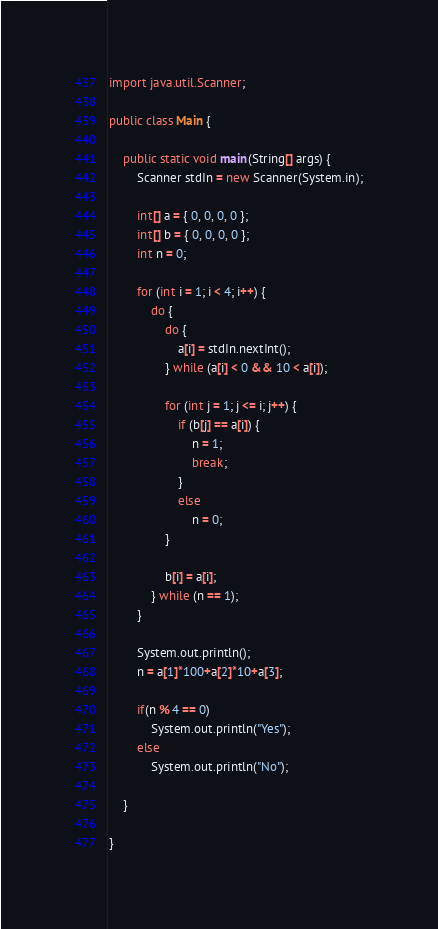Convert code to text. <code><loc_0><loc_0><loc_500><loc_500><_Java_>import java.util.Scanner;

public class Main {

	public static void main(String[] args) {
		Scanner stdIn = new Scanner(System.in);

		int[] a = { 0, 0, 0, 0 };
		int[] b = { 0, 0, 0, 0 };
		int n = 0;

		for (int i = 1; i < 4; i++) {
			do {
				do {
					a[i] = stdIn.nextInt();
				} while (a[i] < 0 && 10 < a[i]);

				for (int j = 1; j <= i; j++) {
					if (b[j] == a[i]) {
						n = 1;
						break;
					}
					else
						n = 0;
				}

				b[i] = a[i];
			} while (n == 1);
		}

		System.out.println();
		n = a[1]*100+a[2]*10+a[3];

		if(n % 4 == 0)
			System.out.println("Yes");
		else
			System.out.println("No");

	}

}
</code> 